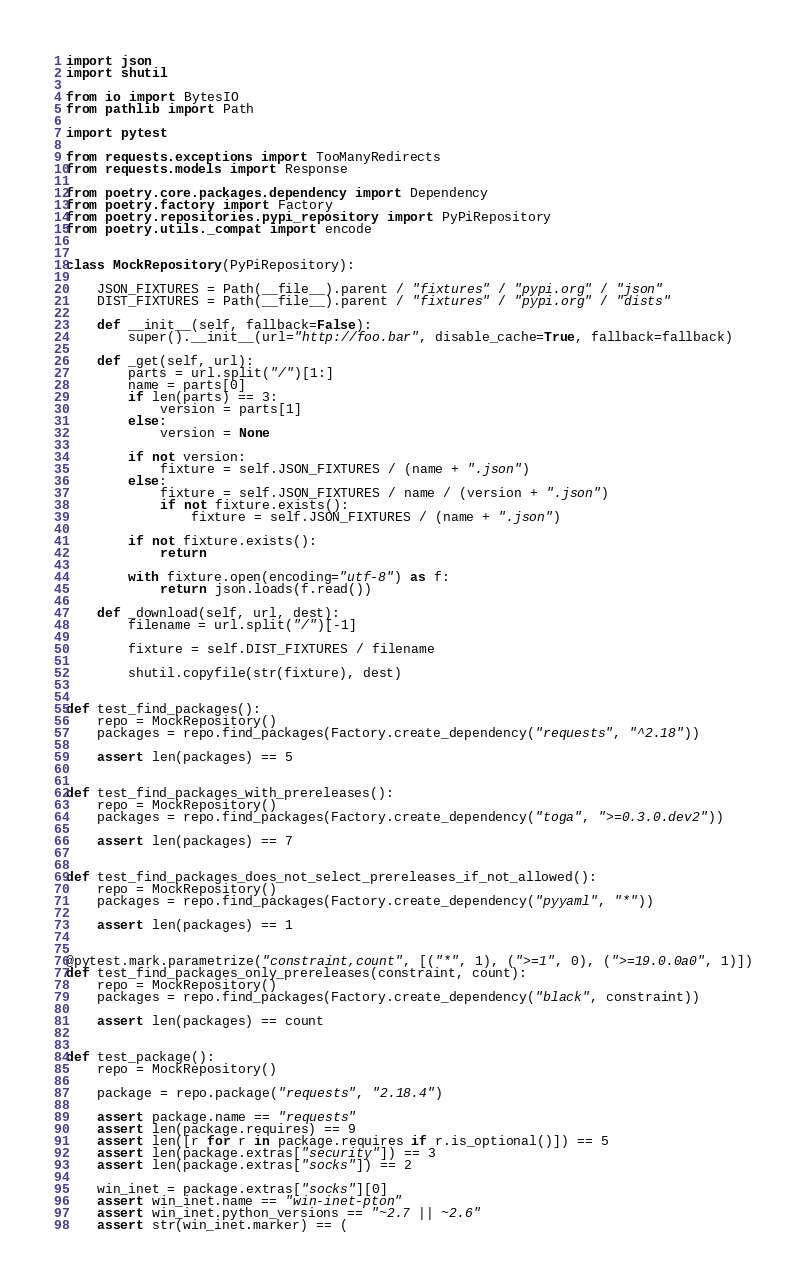<code> <loc_0><loc_0><loc_500><loc_500><_Python_>import json
import shutil

from io import BytesIO
from pathlib import Path

import pytest

from requests.exceptions import TooManyRedirects
from requests.models import Response

from poetry.core.packages.dependency import Dependency
from poetry.factory import Factory
from poetry.repositories.pypi_repository import PyPiRepository
from poetry.utils._compat import encode


class MockRepository(PyPiRepository):

    JSON_FIXTURES = Path(__file__).parent / "fixtures" / "pypi.org" / "json"
    DIST_FIXTURES = Path(__file__).parent / "fixtures" / "pypi.org" / "dists"

    def __init__(self, fallback=False):
        super().__init__(url="http://foo.bar", disable_cache=True, fallback=fallback)

    def _get(self, url):
        parts = url.split("/")[1:]
        name = parts[0]
        if len(parts) == 3:
            version = parts[1]
        else:
            version = None

        if not version:
            fixture = self.JSON_FIXTURES / (name + ".json")
        else:
            fixture = self.JSON_FIXTURES / name / (version + ".json")
            if not fixture.exists():
                fixture = self.JSON_FIXTURES / (name + ".json")

        if not fixture.exists():
            return

        with fixture.open(encoding="utf-8") as f:
            return json.loads(f.read())

    def _download(self, url, dest):
        filename = url.split("/")[-1]

        fixture = self.DIST_FIXTURES / filename

        shutil.copyfile(str(fixture), dest)


def test_find_packages():
    repo = MockRepository()
    packages = repo.find_packages(Factory.create_dependency("requests", "^2.18"))

    assert len(packages) == 5


def test_find_packages_with_prereleases():
    repo = MockRepository()
    packages = repo.find_packages(Factory.create_dependency("toga", ">=0.3.0.dev2"))

    assert len(packages) == 7


def test_find_packages_does_not_select_prereleases_if_not_allowed():
    repo = MockRepository()
    packages = repo.find_packages(Factory.create_dependency("pyyaml", "*"))

    assert len(packages) == 1


@pytest.mark.parametrize("constraint,count", [("*", 1), (">=1", 0), (">=19.0.0a0", 1)])
def test_find_packages_only_prereleases(constraint, count):
    repo = MockRepository()
    packages = repo.find_packages(Factory.create_dependency("black", constraint))

    assert len(packages) == count


def test_package():
    repo = MockRepository()

    package = repo.package("requests", "2.18.4")

    assert package.name == "requests"
    assert len(package.requires) == 9
    assert len([r for r in package.requires if r.is_optional()]) == 5
    assert len(package.extras["security"]) == 3
    assert len(package.extras["socks"]) == 2

    win_inet = package.extras["socks"][0]
    assert win_inet.name == "win-inet-pton"
    assert win_inet.python_versions == "~2.7 || ~2.6"
    assert str(win_inet.marker) == (</code> 